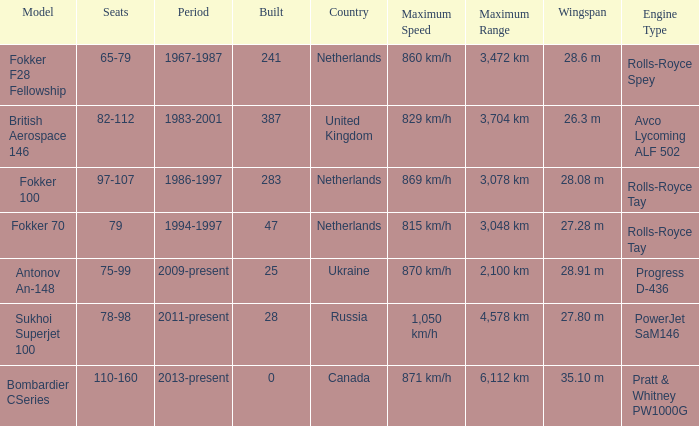How many cabins were built in the time between 1967-1987? 241.0. 